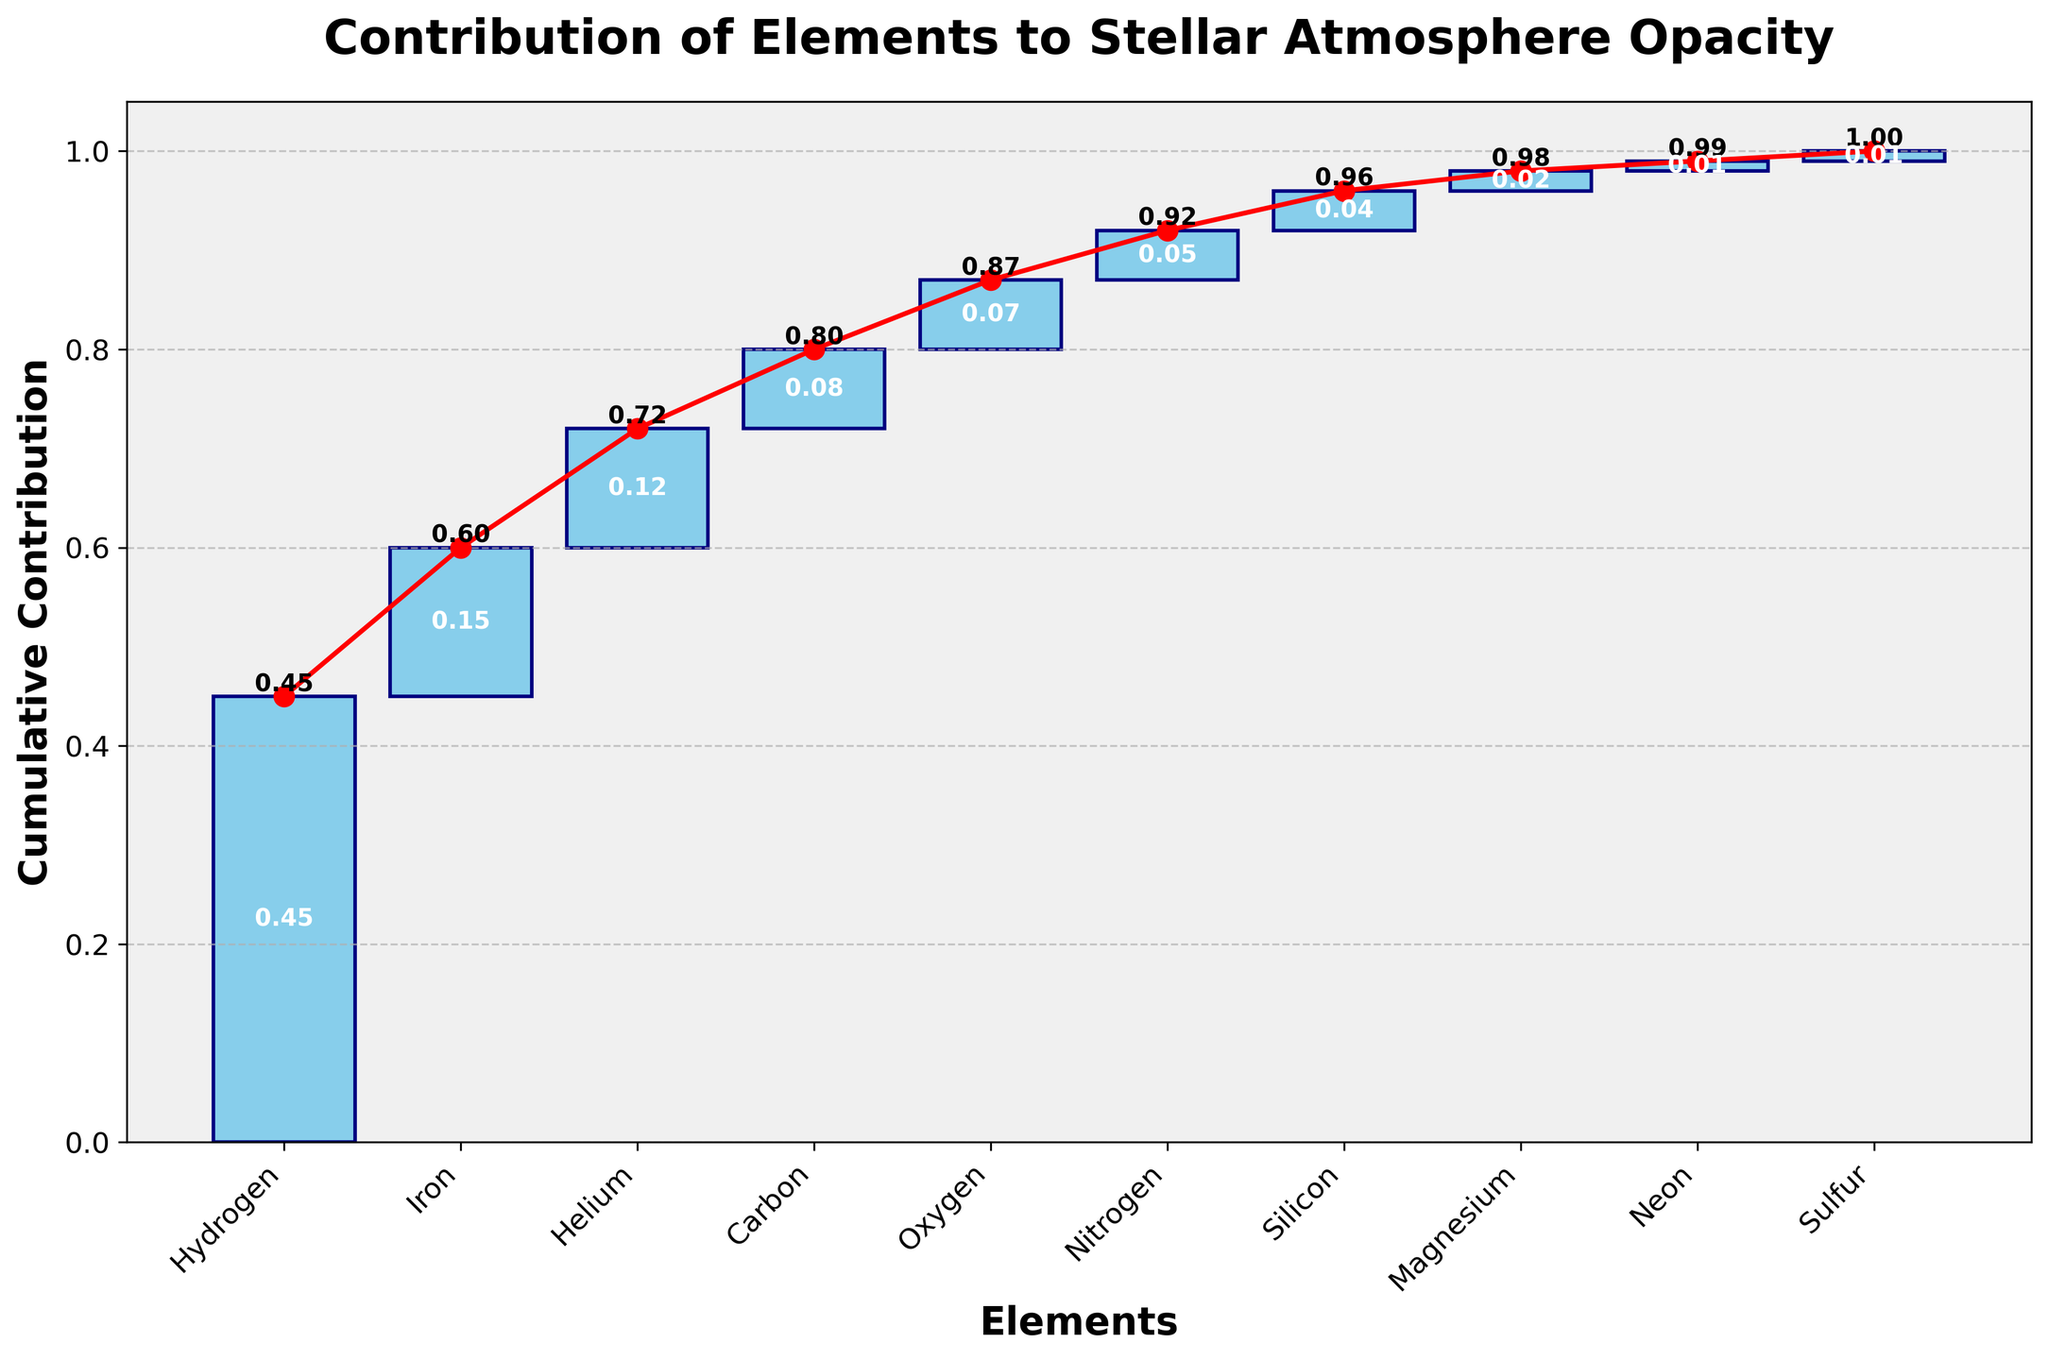What's the title of the plot? The title is displayed prominently at the top of the figure in bold text.
Answer: Contribution of Elements to Stellar Atmosphere Opacity Which element has the highest contribution to the opacity? The highest bar in the chart represents Hydrogen, contributing 0.45.
Answer: Hydrogen What is the cumulative contribution of Hydrogen and Iron? The cumulative contribution can be found by summing the individual contributions of Hydrogen (0.45) and Iron (0.15).
Answer: 0.60 How many total elements are represented in the chart? The x-axis labels each element, and counting these labels gives the total number of elements.
Answer: 10 Which element contributes 0.12 to the opacity? The bars show each element's contribution, and the label for 0.12 corresponds to Helium.
Answer: Helium What is the cumulative contribution up to Carbon? The cumulative contributions appear above each bar and the cumulative value for Carbon is shown as 0.80.
Answer: 0.80 Compare the contributions of Oxygen and Magnesium. Which one is higher and by how much? The bar for Oxygen shows a contribution of 0.07, while Magnesium has 0.02. Subtracting these gives the difference (0.07 - 0.02).
Answer: Oxygen by 0.05 What is the average contribution of the elements shown in the chart? Sum all contributions (0.45 + 0.15 + 0.12 + 0.08 + 0.07 + 0.05 + 0.04 + 0.02 + 0.01 + 0.01) and divide by the number of elements (10). The sum is 1.00, and the average is 1.00 / 10.
Answer: 0.10 What is the cumulative contribution at the end of the chart? The final red dot at the end of the plot represents the total cumulative contribution of all elements.
Answer: 1.00 Which elements have equal contributions to the opacity? The bars for Neon and Sulfur both show contributions of 0.01, indicating equal contributions.
Answer: Neon and Sulfur 